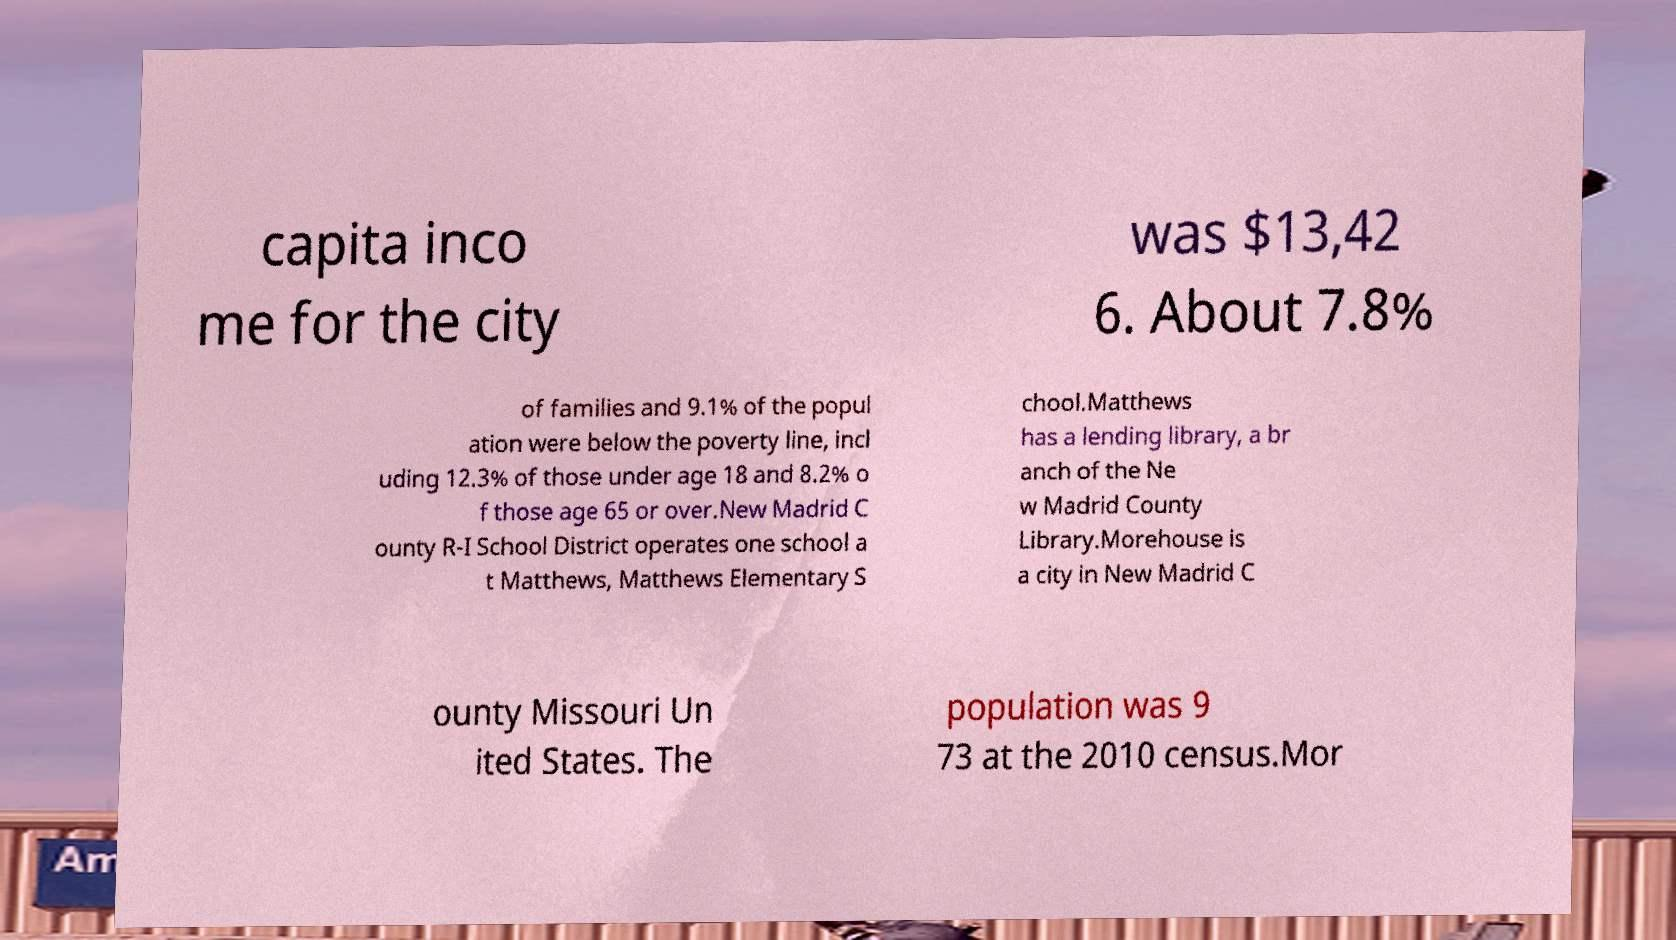Can you accurately transcribe the text from the provided image for me? capita inco me for the city was $13,42 6. About 7.8% of families and 9.1% of the popul ation were below the poverty line, incl uding 12.3% of those under age 18 and 8.2% o f those age 65 or over.New Madrid C ounty R-I School District operates one school a t Matthews, Matthews Elementary S chool.Matthews has a lending library, a br anch of the Ne w Madrid County Library.Morehouse is a city in New Madrid C ounty Missouri Un ited States. The population was 9 73 at the 2010 census.Mor 